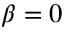<formula> <loc_0><loc_0><loc_500><loc_500>\beta = 0</formula> 